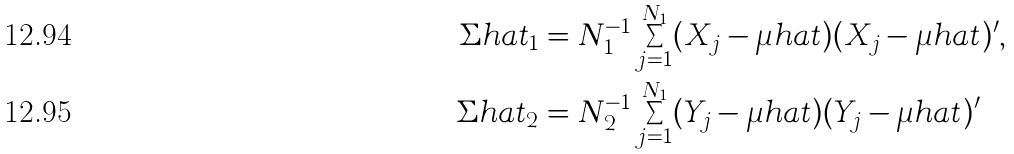<formula> <loc_0><loc_0><loc_500><loc_500>\Sigma h a t _ { 1 } & = N _ { 1 } ^ { - 1 } \sum _ { j = 1 } ^ { N _ { 1 } } ( X _ { j } - \mu h a t ) ( X _ { j } - \mu h a t ) ^ { \prime } , \\ \Sigma h a t _ { 2 } & = N _ { 2 } ^ { - 1 } \sum _ { j = 1 } ^ { N _ { 1 } } ( Y _ { j } - \mu h a t ) ( Y _ { j } - \mu h a t ) ^ { \prime }</formula> 